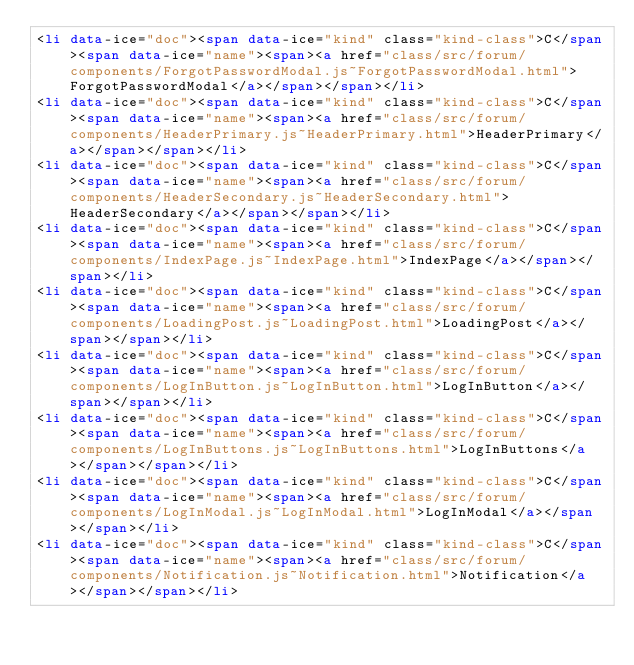<code> <loc_0><loc_0><loc_500><loc_500><_HTML_><li data-ice="doc"><span data-ice="kind" class="kind-class">C</span><span data-ice="name"><span><a href="class/src/forum/components/ForgotPasswordModal.js~ForgotPasswordModal.html">ForgotPasswordModal</a></span></span></li>
<li data-ice="doc"><span data-ice="kind" class="kind-class">C</span><span data-ice="name"><span><a href="class/src/forum/components/HeaderPrimary.js~HeaderPrimary.html">HeaderPrimary</a></span></span></li>
<li data-ice="doc"><span data-ice="kind" class="kind-class">C</span><span data-ice="name"><span><a href="class/src/forum/components/HeaderSecondary.js~HeaderSecondary.html">HeaderSecondary</a></span></span></li>
<li data-ice="doc"><span data-ice="kind" class="kind-class">C</span><span data-ice="name"><span><a href="class/src/forum/components/IndexPage.js~IndexPage.html">IndexPage</a></span></span></li>
<li data-ice="doc"><span data-ice="kind" class="kind-class">C</span><span data-ice="name"><span><a href="class/src/forum/components/LoadingPost.js~LoadingPost.html">LoadingPost</a></span></span></li>
<li data-ice="doc"><span data-ice="kind" class="kind-class">C</span><span data-ice="name"><span><a href="class/src/forum/components/LogInButton.js~LogInButton.html">LogInButton</a></span></span></li>
<li data-ice="doc"><span data-ice="kind" class="kind-class">C</span><span data-ice="name"><span><a href="class/src/forum/components/LogInButtons.js~LogInButtons.html">LogInButtons</a></span></span></li>
<li data-ice="doc"><span data-ice="kind" class="kind-class">C</span><span data-ice="name"><span><a href="class/src/forum/components/LogInModal.js~LogInModal.html">LogInModal</a></span></span></li>
<li data-ice="doc"><span data-ice="kind" class="kind-class">C</span><span data-ice="name"><span><a href="class/src/forum/components/Notification.js~Notification.html">Notification</a></span></span></li></code> 